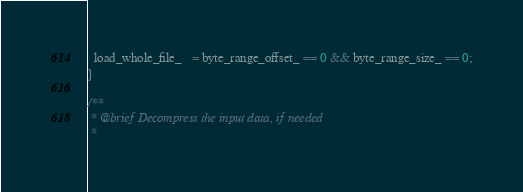<code> <loc_0><loc_0><loc_500><loc_500><_Cuda_>  load_whole_file_   = byte_range_offset_ == 0 && byte_range_size_ == 0;
}

/**
 * @brief Decompress the input data, if needed
 *</code> 